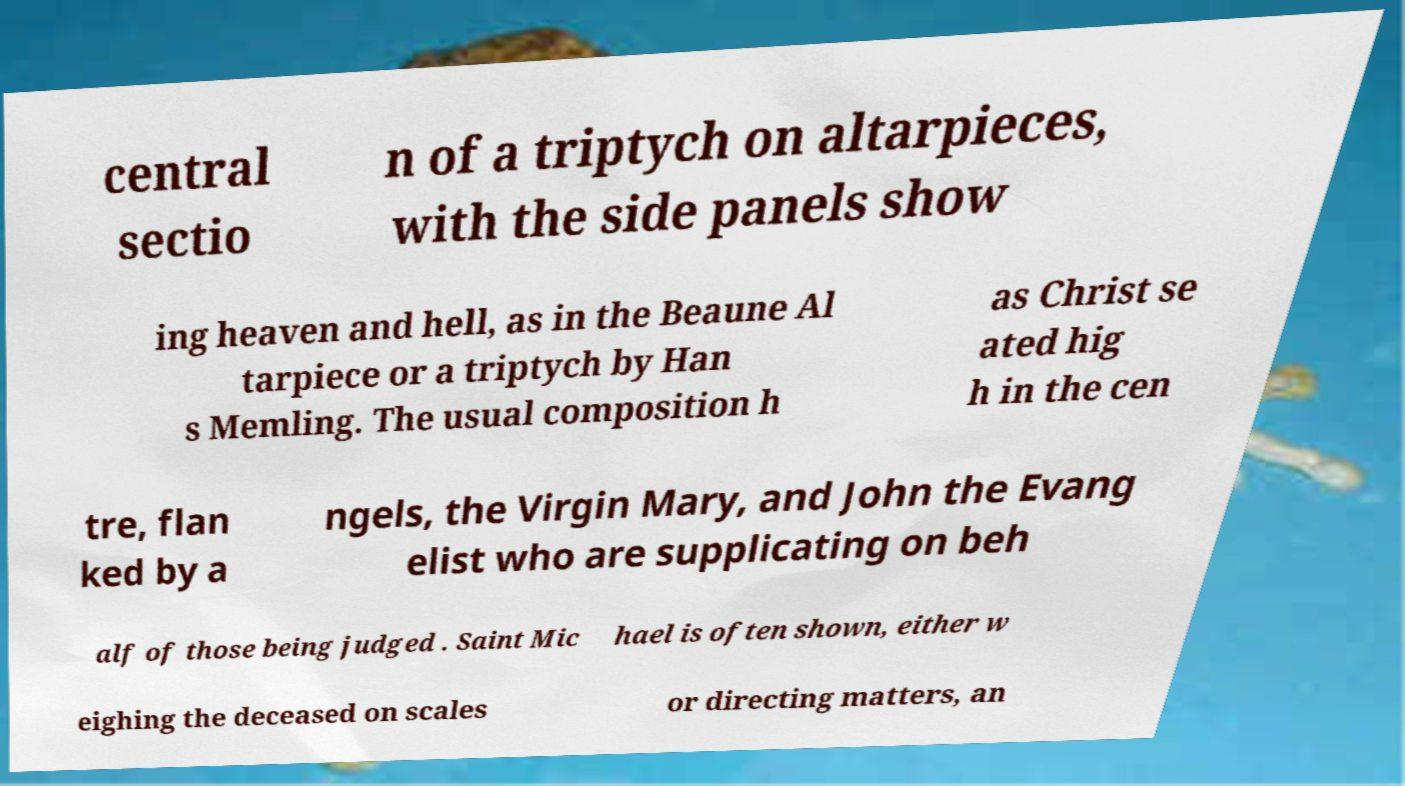What messages or text are displayed in this image? I need them in a readable, typed format. central sectio n of a triptych on altarpieces, with the side panels show ing heaven and hell, as in the Beaune Al tarpiece or a triptych by Han s Memling. The usual composition h as Christ se ated hig h in the cen tre, flan ked by a ngels, the Virgin Mary, and John the Evang elist who are supplicating on beh alf of those being judged . Saint Mic hael is often shown, either w eighing the deceased on scales or directing matters, an 